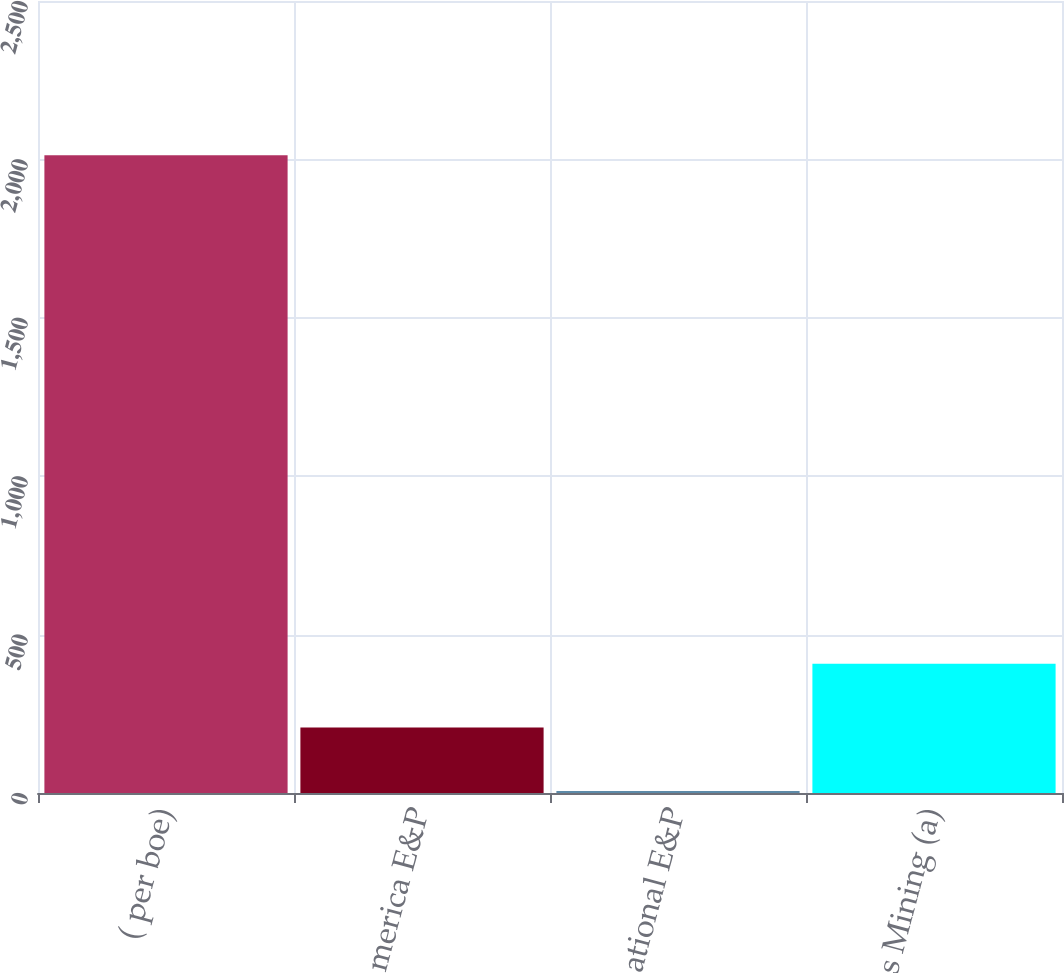<chart> <loc_0><loc_0><loc_500><loc_500><bar_chart><fcel>( per boe)<fcel>North America E&P<fcel>International E&P<fcel>Oil Sands Mining (a)<nl><fcel>2013<fcel>207.02<fcel>6.36<fcel>407.68<nl></chart> 